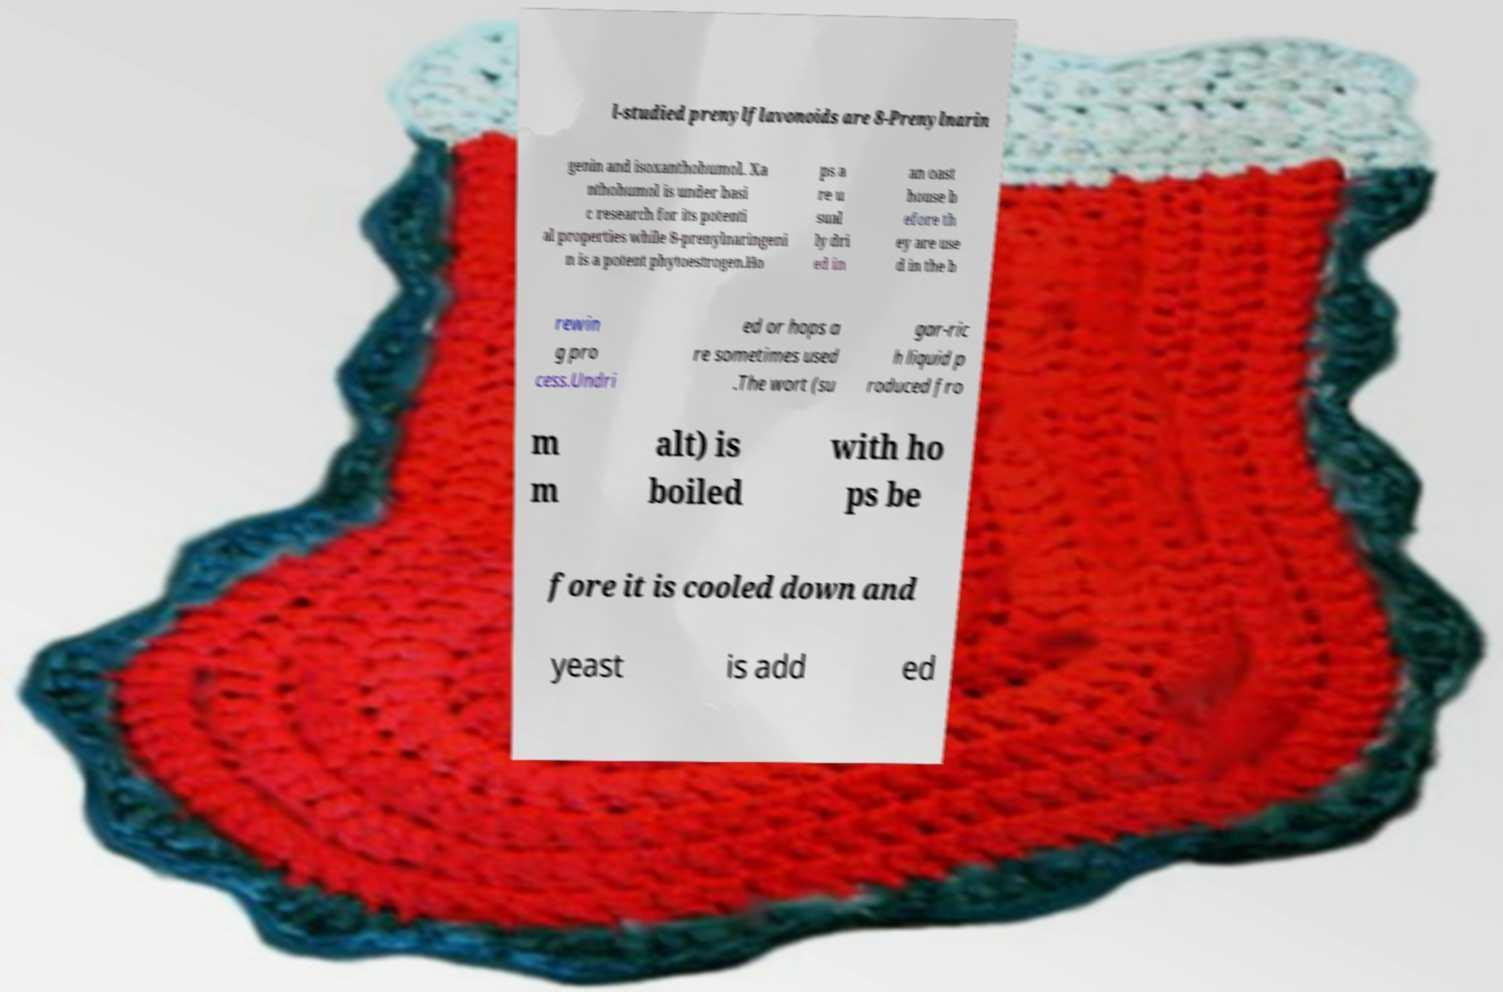For documentation purposes, I need the text within this image transcribed. Could you provide that? l-studied prenylflavonoids are 8-Prenylnarin genin and isoxanthohumol. Xa nthohumol is under basi c research for its potenti al properties while 8-prenylnaringeni n is a potent phytoestrogen.Ho ps a re u sual ly dri ed in an oast house b efore th ey are use d in the b rewin g pro cess.Undri ed or hops a re sometimes used .The wort (su gar-ric h liquid p roduced fro m m alt) is boiled with ho ps be fore it is cooled down and yeast is add ed 